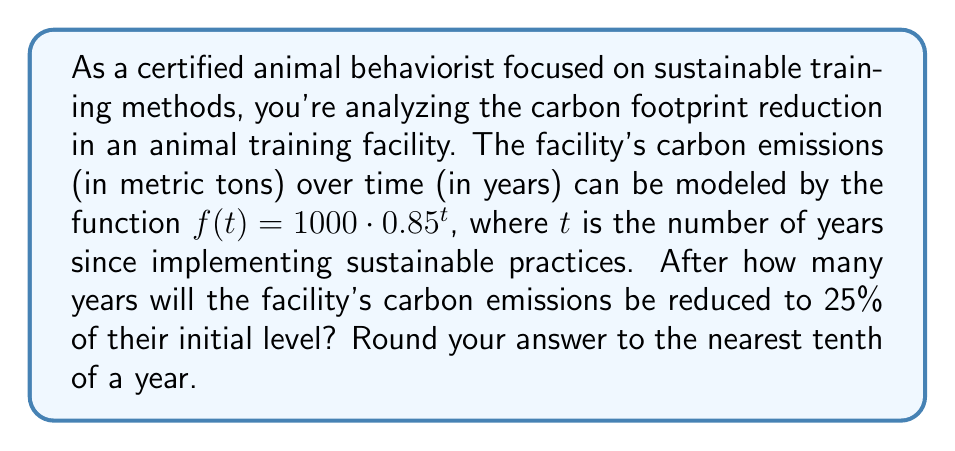Solve this math problem. To solve this problem, we need to use logarithms. Let's approach this step-by-step:

1) We want to find $t$ when $f(t)$ is 25% of the initial value.
   Initial value: $f(0) = 1000 \cdot 0.85^0 = 1000$
   25% of initial value: $0.25 \cdot 1000 = 250$

2) So, we need to solve the equation:
   $1000 \cdot 0.85^t = 250$

3) Divide both sides by 1000:
   $0.85^t = 0.25$

4) Take the natural logarithm of both sides:
   $\ln(0.85^t) = \ln(0.25)$

5) Using the logarithm property $\ln(a^b) = b\ln(a)$:
   $t \cdot \ln(0.85) = \ln(0.25)$

6) Solve for $t$:
   $t = \frac{\ln(0.25)}{\ln(0.85)}$

7) Calculate using a calculator:
   $t \approx 8.9657$

8) Rounding to the nearest tenth:
   $t \approx 9.0$ years
Answer: The facility's carbon emissions will be reduced to 25% of their initial level after approximately 9.0 years. 